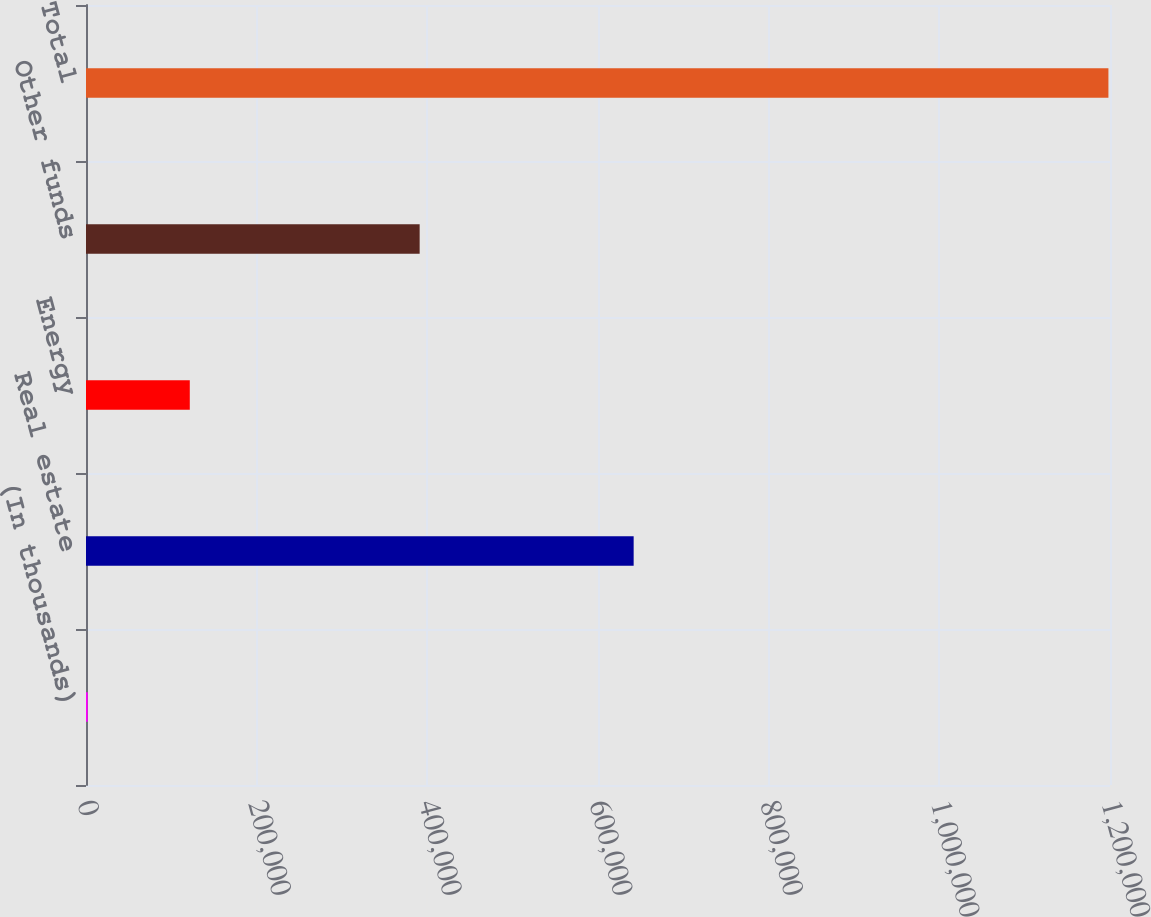Convert chart to OTSL. <chart><loc_0><loc_0><loc_500><loc_500><bar_chart><fcel>(In thousands)<fcel>Real estate<fcel>Energy<fcel>Other funds<fcel>Total<nl><fcel>2016<fcel>641783<fcel>121629<fcel>391002<fcel>1.19815e+06<nl></chart> 